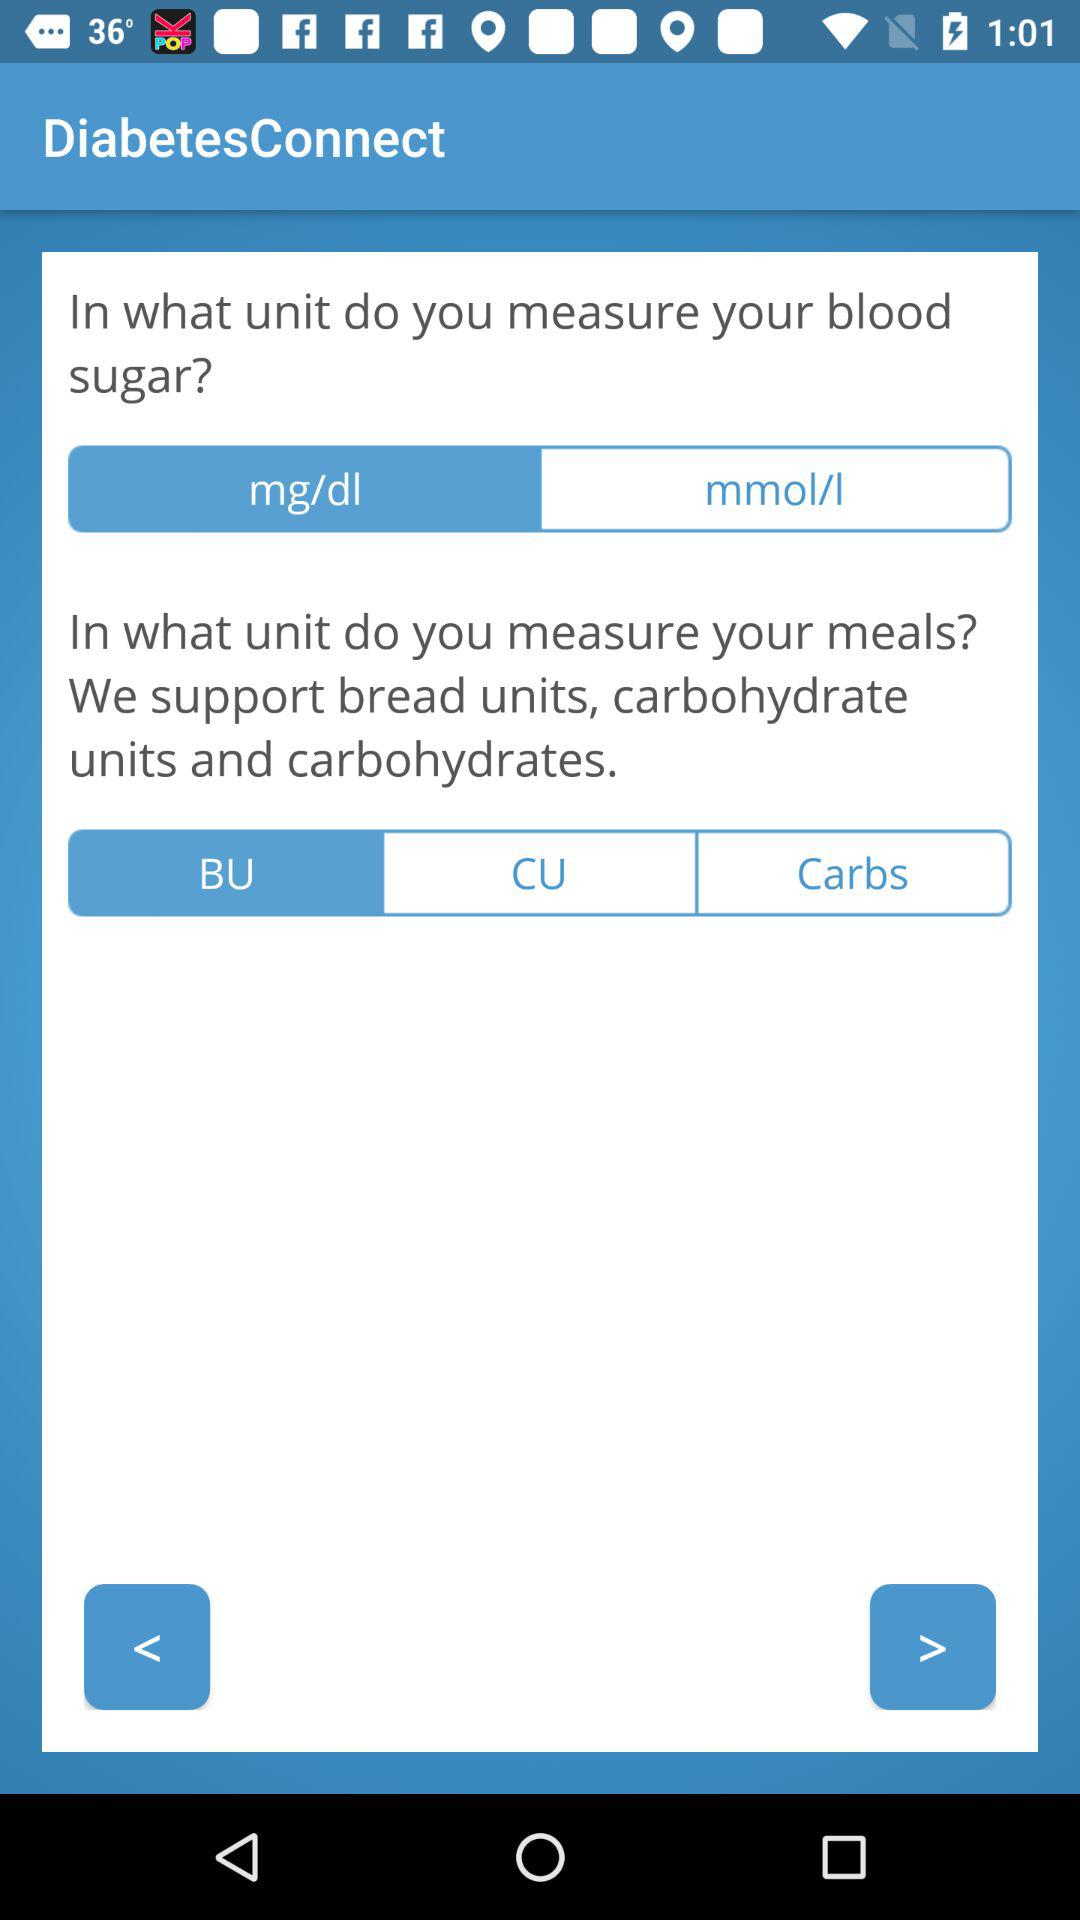What is the unit of measure for meals? The unit is "BU". 